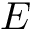Convert formula to latex. <formula><loc_0><loc_0><loc_500><loc_500>E</formula> 